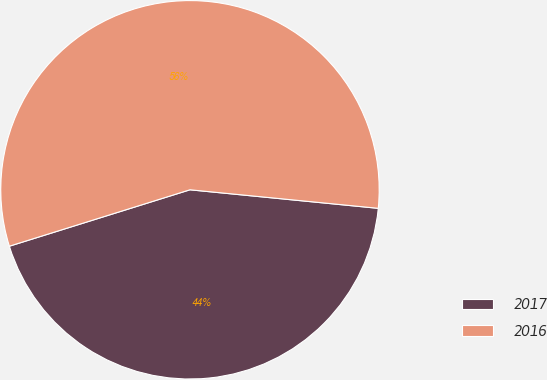Convert chart to OTSL. <chart><loc_0><loc_0><loc_500><loc_500><pie_chart><fcel>2017<fcel>2016<nl><fcel>43.62%<fcel>56.38%<nl></chart> 